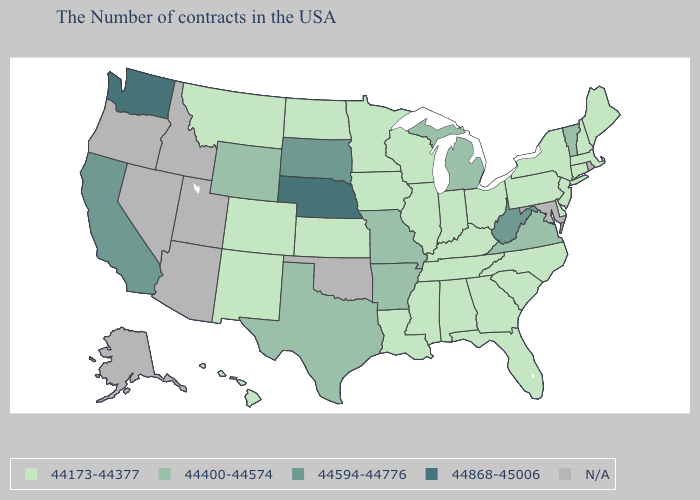What is the value of Missouri?
Answer briefly. 44400-44574. Does West Virginia have the highest value in the South?
Answer briefly. Yes. What is the value of Mississippi?
Quick response, please. 44173-44377. Name the states that have a value in the range 44400-44574?
Answer briefly. Vermont, Virginia, Michigan, Missouri, Arkansas, Texas, Wyoming. Does Georgia have the lowest value in the South?
Give a very brief answer. Yes. Does Arkansas have the highest value in the USA?
Concise answer only. No. What is the value of Nevada?
Quick response, please. N/A. What is the highest value in the USA?
Write a very short answer. 44868-45006. Does the first symbol in the legend represent the smallest category?
Quick response, please. Yes. Does Alabama have the lowest value in the USA?
Short answer required. Yes. Which states have the lowest value in the MidWest?
Short answer required. Ohio, Indiana, Wisconsin, Illinois, Minnesota, Iowa, Kansas, North Dakota. What is the value of Kansas?
Quick response, please. 44173-44377. What is the value of Pennsylvania?
Answer briefly. 44173-44377. Name the states that have a value in the range 44594-44776?
Give a very brief answer. West Virginia, South Dakota, California. Does the map have missing data?
Be succinct. Yes. 